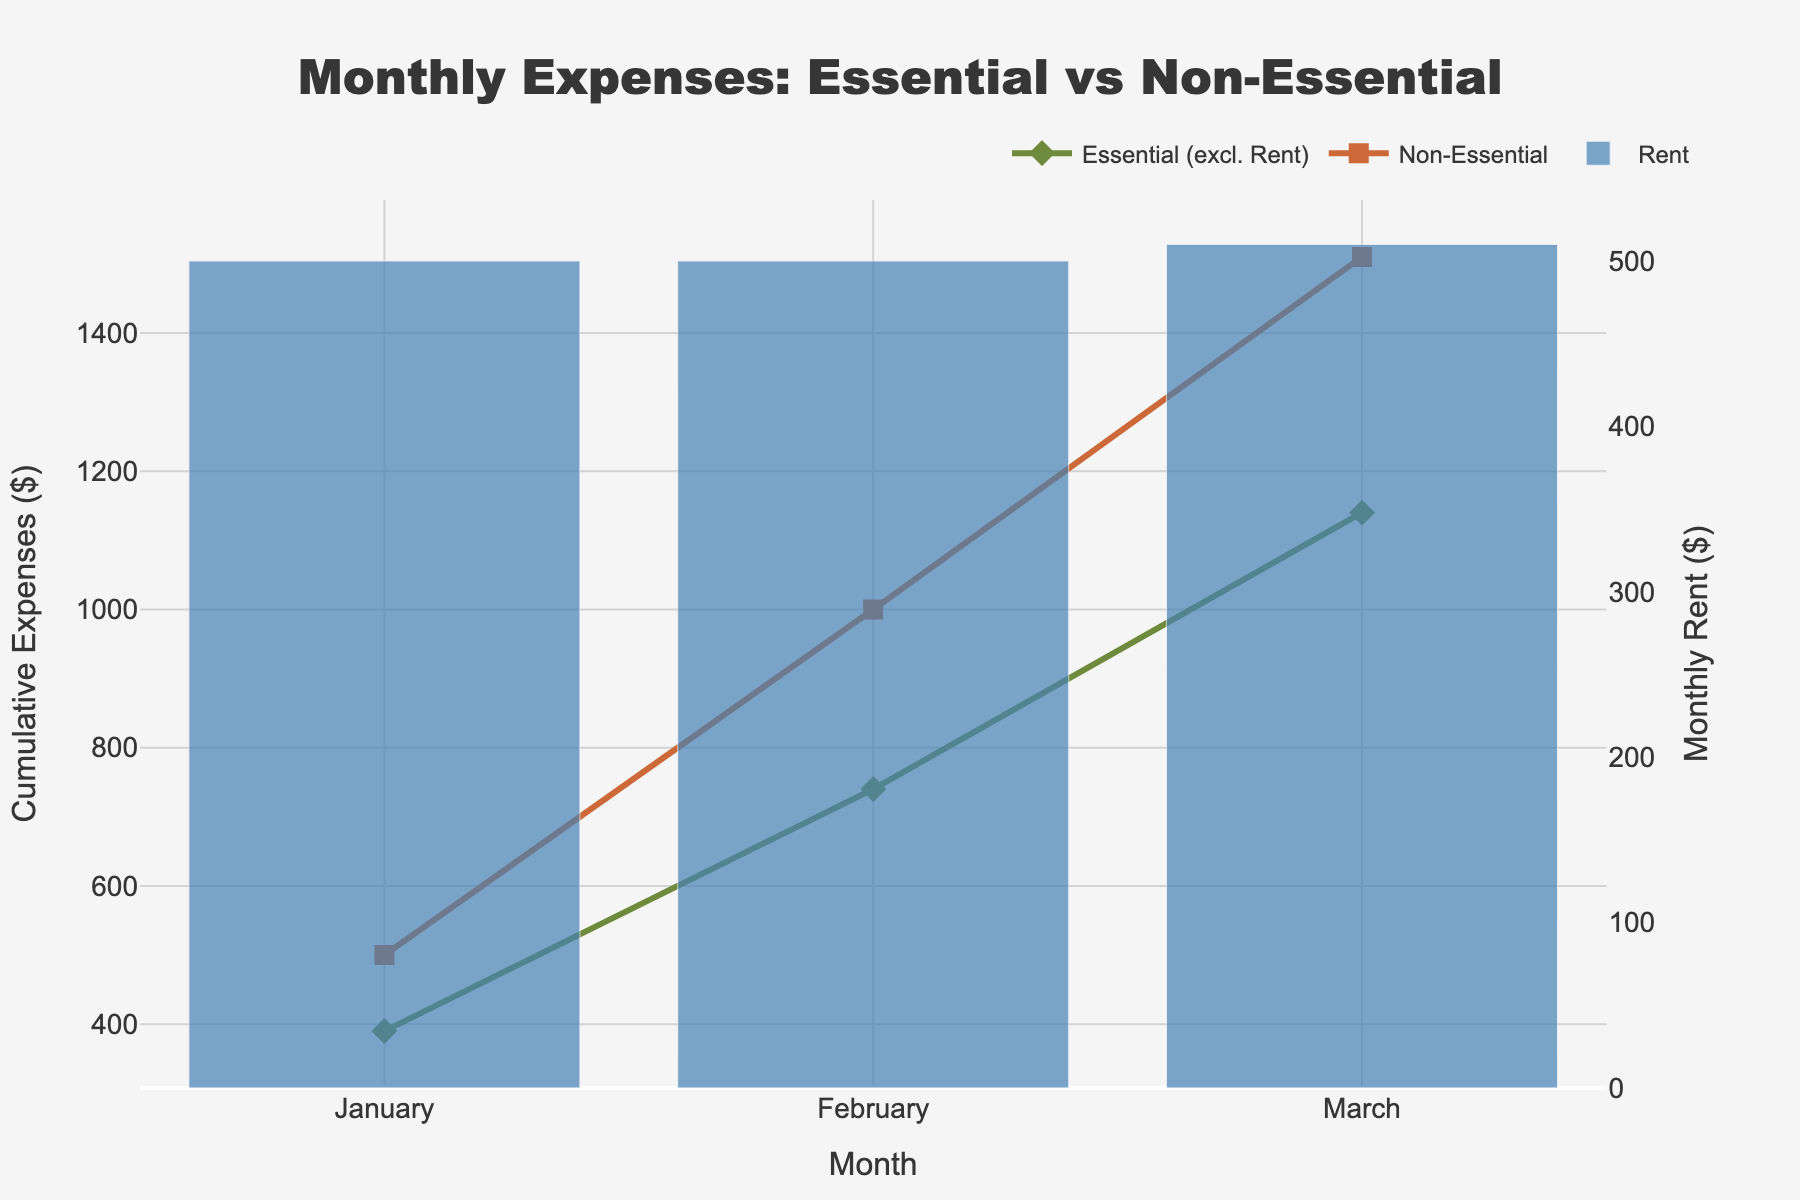How many months are displayed in the figure? The figure shows data for "Rent," "Essential (excl. Rent)" and "Non-Essential" expenses across different months. Count the number of distinct months on the x-axis.
Answer: 3 What is the title of the figure? Look at the top part of the figure for the title.
Answer: Monthly Expenses: Essential vs Non-Essential What color is used to represent "Rent" in the bar chart? Observe the color of the bars in the figure which denote "Rent."
Answer: Blue Which category had the highest cumulative expenses by March? Compare the cumulative values of "Essential (excl. Rent)" and "Non-Essential" by March.
Answer: Essential (excl. Rent) What was the cumulative "Non-Essential" expenditure by the end of February? Look at the "Non-Essential" trace (square markers) and note its cumulative value for February.
Answer: 720 Between January and March, which month had the lowest "Rent" expenditure? Check the bar heights for "Rent" across January, February, and March to find the lowest one.
Answer: January How does the "Essential (excl. Rent)" cumulative expense progress over each month? Track the line for "Essential (excl. Rent)" and observe how the cumulative expense increases month by month using the markers.
Answer: Increases Compare the "Rent" expenditure in January and February. Look at the bar heights for "Rent" in January and February; compare their values.
Answer: Equal Is the cumulative "Essential (excl. Rent)" expense higher or lower than "Non-Essential" in January? Compare the y-values of the "Essential (excl. Rent)" and "Non-Essential" lines (diamond and square markers) for January.
Answer: Lower 